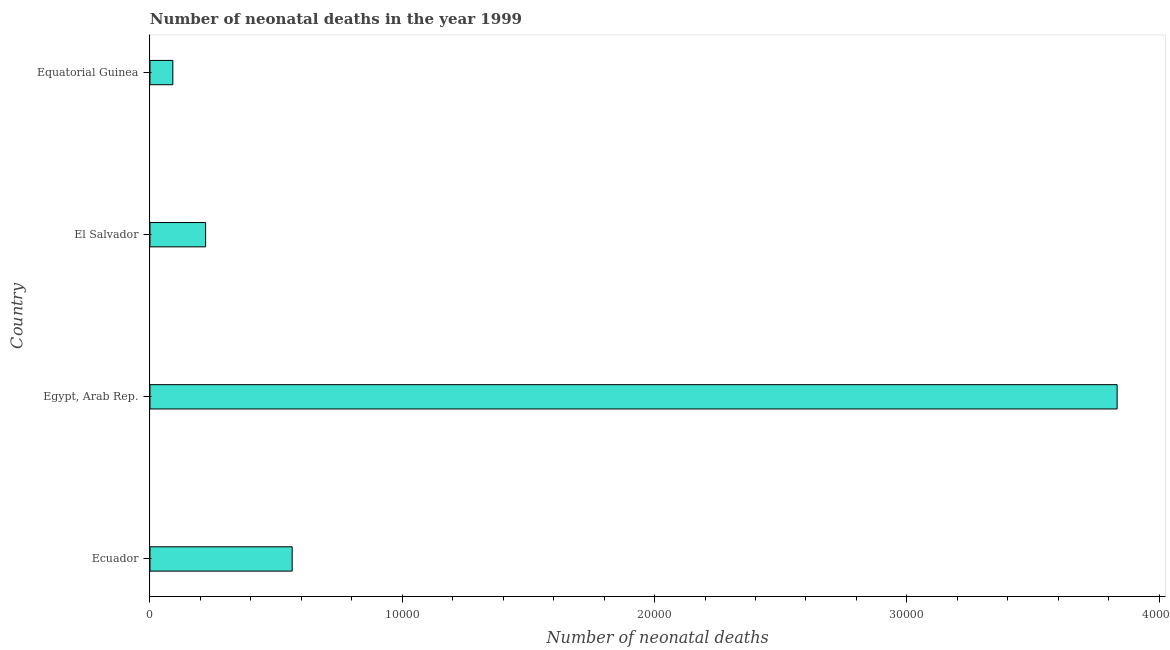Does the graph contain any zero values?
Keep it short and to the point. No. Does the graph contain grids?
Provide a succinct answer. No. What is the title of the graph?
Your response must be concise. Number of neonatal deaths in the year 1999. What is the label or title of the X-axis?
Your answer should be compact. Number of neonatal deaths. What is the number of neonatal deaths in Egypt, Arab Rep.?
Make the answer very short. 3.83e+04. Across all countries, what is the maximum number of neonatal deaths?
Your response must be concise. 3.83e+04. Across all countries, what is the minimum number of neonatal deaths?
Your answer should be compact. 905. In which country was the number of neonatal deaths maximum?
Provide a short and direct response. Egypt, Arab Rep. In which country was the number of neonatal deaths minimum?
Offer a very short reply. Equatorial Guinea. What is the sum of the number of neonatal deaths?
Your response must be concise. 4.71e+04. What is the difference between the number of neonatal deaths in Egypt, Arab Rep. and El Salvador?
Give a very brief answer. 3.61e+04. What is the average number of neonatal deaths per country?
Offer a terse response. 1.18e+04. What is the median number of neonatal deaths?
Give a very brief answer. 3920.5. What is the ratio of the number of neonatal deaths in Ecuador to that in Equatorial Guinea?
Provide a short and direct response. 6.23. Is the number of neonatal deaths in Egypt, Arab Rep. less than that in El Salvador?
Ensure brevity in your answer.  No. Is the difference between the number of neonatal deaths in Ecuador and Equatorial Guinea greater than the difference between any two countries?
Provide a succinct answer. No. What is the difference between the highest and the second highest number of neonatal deaths?
Your answer should be compact. 3.27e+04. Is the sum of the number of neonatal deaths in El Salvador and Equatorial Guinea greater than the maximum number of neonatal deaths across all countries?
Give a very brief answer. No. What is the difference between the highest and the lowest number of neonatal deaths?
Your answer should be very brief. 3.74e+04. How many bars are there?
Your response must be concise. 4. How many countries are there in the graph?
Keep it short and to the point. 4. What is the difference between two consecutive major ticks on the X-axis?
Your answer should be very brief. 10000. What is the Number of neonatal deaths of Ecuador?
Keep it short and to the point. 5636. What is the Number of neonatal deaths in Egypt, Arab Rep.?
Provide a succinct answer. 3.83e+04. What is the Number of neonatal deaths in El Salvador?
Give a very brief answer. 2205. What is the Number of neonatal deaths of Equatorial Guinea?
Your answer should be very brief. 905. What is the difference between the Number of neonatal deaths in Ecuador and Egypt, Arab Rep.?
Offer a terse response. -3.27e+04. What is the difference between the Number of neonatal deaths in Ecuador and El Salvador?
Make the answer very short. 3431. What is the difference between the Number of neonatal deaths in Ecuador and Equatorial Guinea?
Provide a succinct answer. 4731. What is the difference between the Number of neonatal deaths in Egypt, Arab Rep. and El Salvador?
Your answer should be compact. 3.61e+04. What is the difference between the Number of neonatal deaths in Egypt, Arab Rep. and Equatorial Guinea?
Provide a short and direct response. 3.74e+04. What is the difference between the Number of neonatal deaths in El Salvador and Equatorial Guinea?
Offer a very short reply. 1300. What is the ratio of the Number of neonatal deaths in Ecuador to that in Egypt, Arab Rep.?
Keep it short and to the point. 0.15. What is the ratio of the Number of neonatal deaths in Ecuador to that in El Salvador?
Your answer should be compact. 2.56. What is the ratio of the Number of neonatal deaths in Ecuador to that in Equatorial Guinea?
Your answer should be compact. 6.23. What is the ratio of the Number of neonatal deaths in Egypt, Arab Rep. to that in El Salvador?
Make the answer very short. 17.39. What is the ratio of the Number of neonatal deaths in Egypt, Arab Rep. to that in Equatorial Guinea?
Ensure brevity in your answer.  42.36. What is the ratio of the Number of neonatal deaths in El Salvador to that in Equatorial Guinea?
Offer a very short reply. 2.44. 